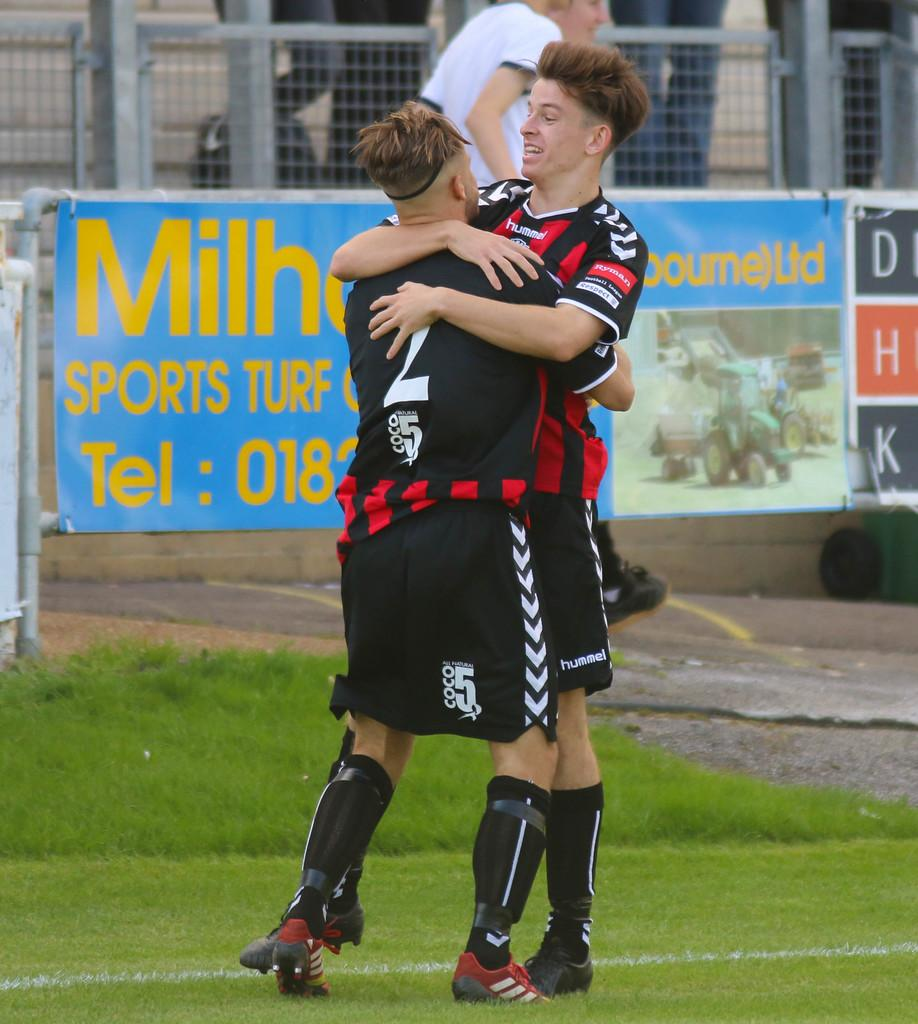<image>
Write a terse but informative summary of the picture. Two players embracing on a field with an advertisement for sports turf behind them. 